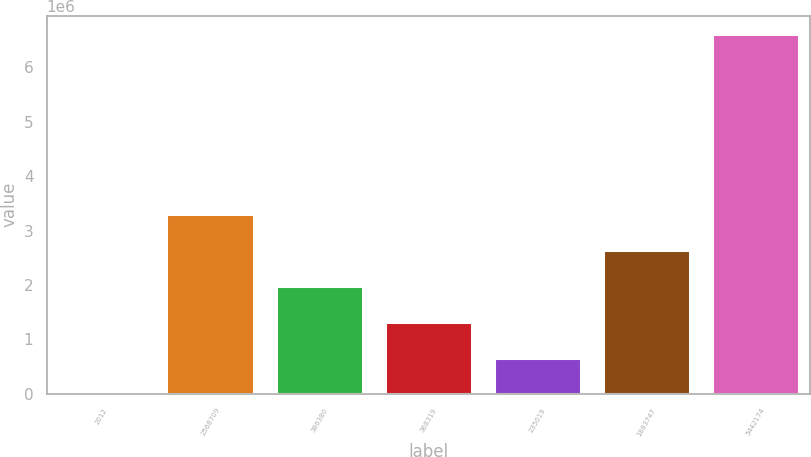Convert chart. <chart><loc_0><loc_0><loc_500><loc_500><bar_chart><fcel>2012<fcel>2568709<fcel>386380<fcel>368319<fcel>235019<fcel>1883747<fcel>5442174<nl><fcel>2011<fcel>3.30891e+06<fcel>1.98615e+06<fcel>1.32477e+06<fcel>663391<fcel>2.64753e+06<fcel>6.61581e+06<nl></chart> 